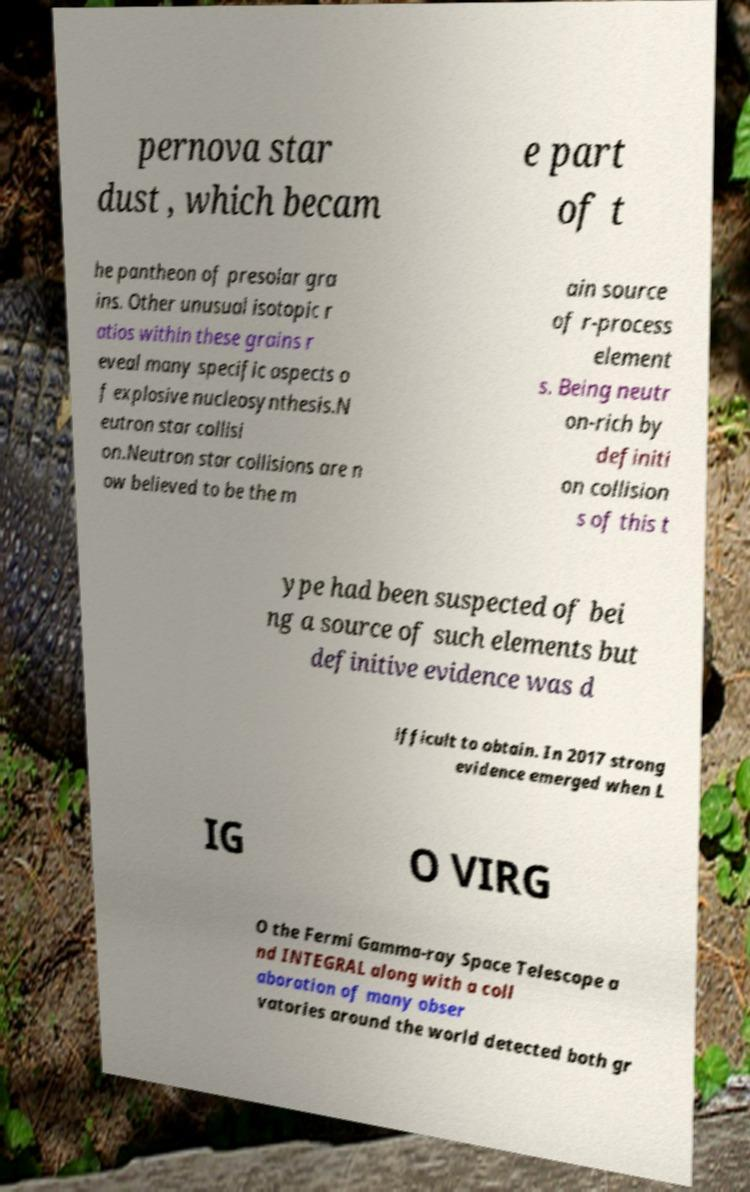Please identify and transcribe the text found in this image. pernova star dust , which becam e part of t he pantheon of presolar gra ins. Other unusual isotopic r atios within these grains r eveal many specific aspects o f explosive nucleosynthesis.N eutron star collisi on.Neutron star collisions are n ow believed to be the m ain source of r-process element s. Being neutr on-rich by definiti on collision s of this t ype had been suspected of bei ng a source of such elements but definitive evidence was d ifficult to obtain. In 2017 strong evidence emerged when L IG O VIRG O the Fermi Gamma-ray Space Telescope a nd INTEGRAL along with a coll aboration of many obser vatories around the world detected both gr 